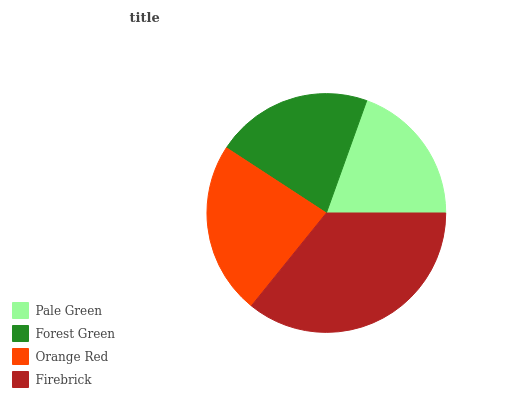Is Pale Green the minimum?
Answer yes or no. Yes. Is Firebrick the maximum?
Answer yes or no. Yes. Is Forest Green the minimum?
Answer yes or no. No. Is Forest Green the maximum?
Answer yes or no. No. Is Forest Green greater than Pale Green?
Answer yes or no. Yes. Is Pale Green less than Forest Green?
Answer yes or no. Yes. Is Pale Green greater than Forest Green?
Answer yes or no. No. Is Forest Green less than Pale Green?
Answer yes or no. No. Is Orange Red the high median?
Answer yes or no. Yes. Is Forest Green the low median?
Answer yes or no. Yes. Is Firebrick the high median?
Answer yes or no. No. Is Pale Green the low median?
Answer yes or no. No. 